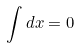<formula> <loc_0><loc_0><loc_500><loc_500>\int d x = 0</formula> 